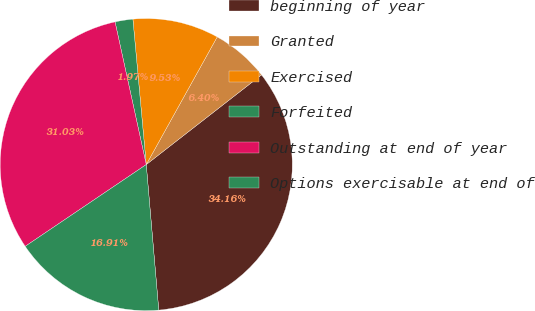Convert chart. <chart><loc_0><loc_0><loc_500><loc_500><pie_chart><fcel>beginning of year<fcel>Granted<fcel>Exercised<fcel>Forfeited<fcel>Outstanding at end of year<fcel>Options exercisable at end of<nl><fcel>34.16%<fcel>6.4%<fcel>9.53%<fcel>1.97%<fcel>31.03%<fcel>16.91%<nl></chart> 